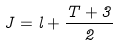Convert formula to latex. <formula><loc_0><loc_0><loc_500><loc_500>J = l + \frac { T + 3 } 2</formula> 